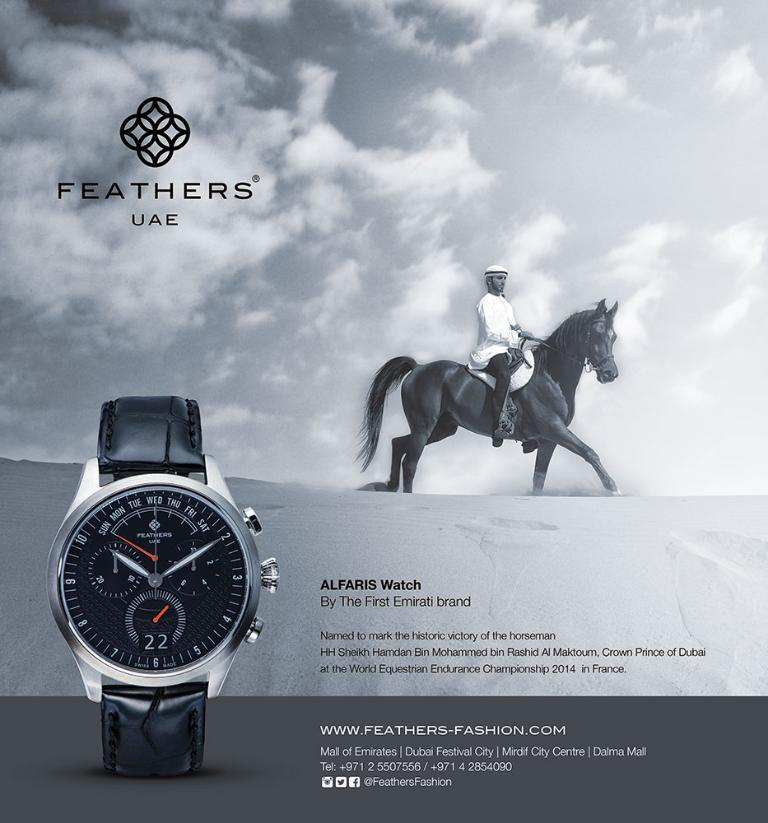Provide a one-sentence caption for the provided image. An Alfaris watch advertisement features a horseback rider. 